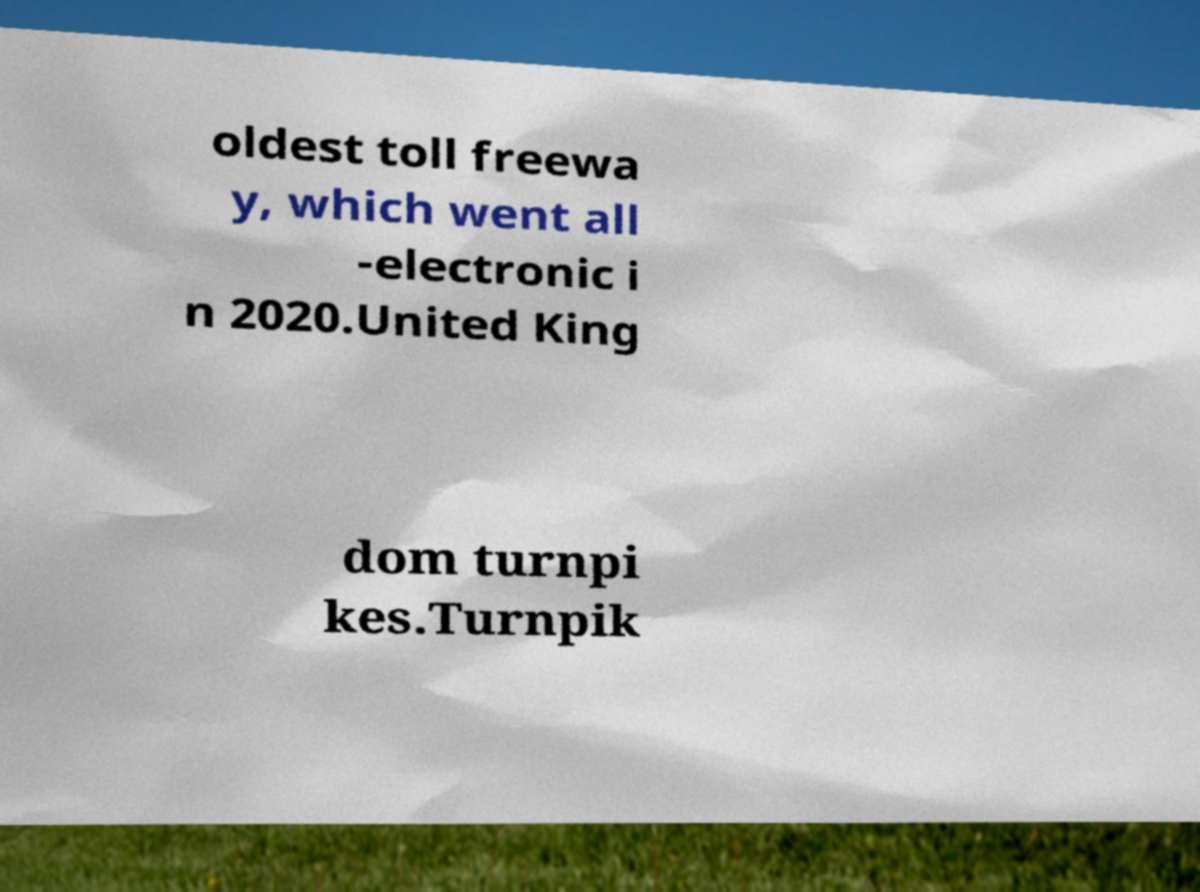Can you read and provide the text displayed in the image?This photo seems to have some interesting text. Can you extract and type it out for me? oldest toll freewa y, which went all -electronic i n 2020.United King dom turnpi kes.Turnpik 